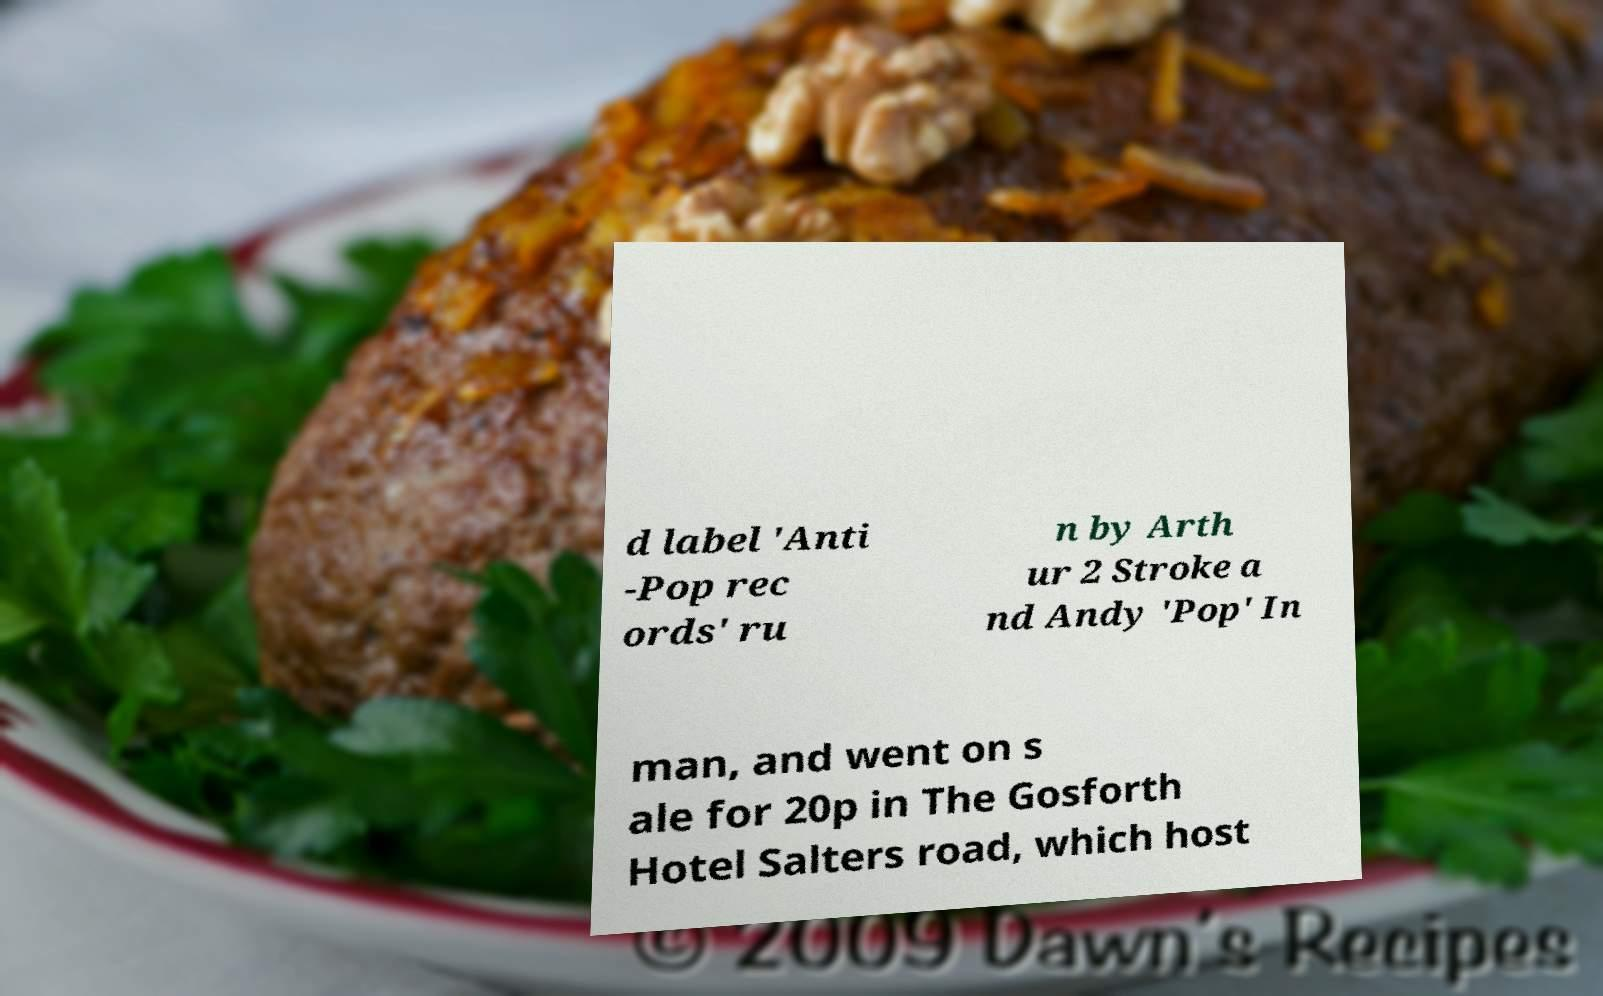Please identify and transcribe the text found in this image. d label 'Anti -Pop rec ords' ru n by Arth ur 2 Stroke a nd Andy 'Pop' In man, and went on s ale for 20p in The Gosforth Hotel Salters road, which host 